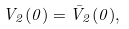Convert formula to latex. <formula><loc_0><loc_0><loc_500><loc_500>V _ { 2 } ( 0 ) = \bar { V } _ { 2 } ( 0 ) ,</formula> 